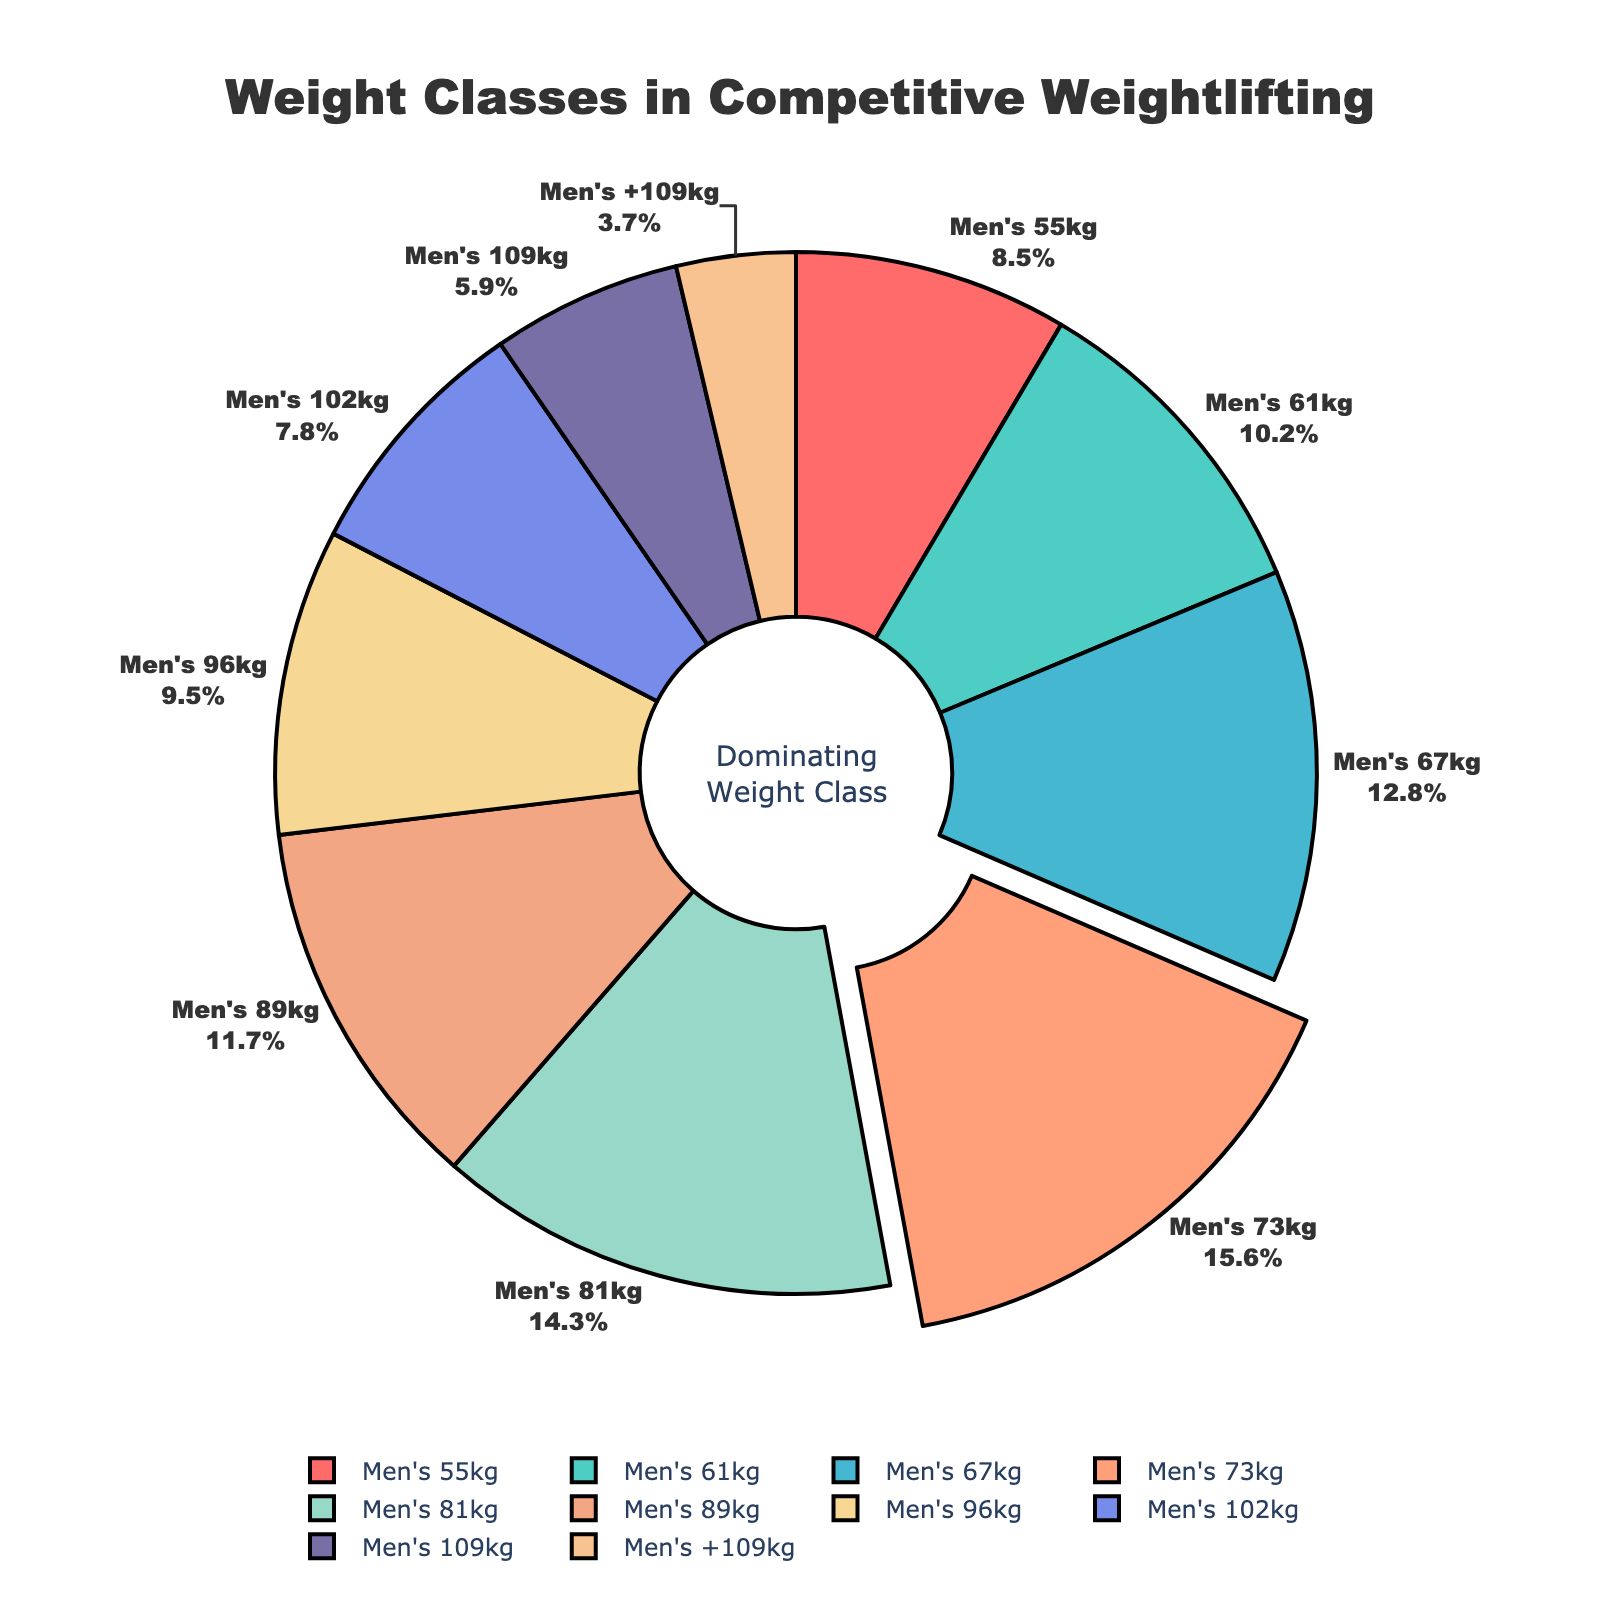Which weight class has the highest percentage? The weight class with the highest percentage will be the one with the largest slice on the pie chart. Observing the chart, the "Men's 73kg" class has the largest slice.
Answer: Men's 73kg What is the combined percentage of the Men's 96kg and Men's 81kg weight classes? To find the combined percentage, add the percentages of Men's 96kg and Men's 81kg. From the chart, Men's 96kg is 9.5% and Men's 81kg is 14.3%. Thus, 9.5% + 14.3% = 23.8%.
Answer: 23.8% Which weight class has the least representation? The weight class with the smallest slice on the pie chart represents the one with the least percentage. Noticing the chart, the "Men's +109kg" class has the smallest slice.
Answer: Men's +109kg How much larger is the percentage of Men's 67kg compared to Men's 55kg? To determine this, subtract the percentage of Men's 55kg from the percentage of Men's 67kg: Men's 67kg is 12.8% and Men's 55kg is 8.5%, so 12.8% - 8.5% = 4.3%.
Answer: 4.3% What is the total percentage of the three most represented weight classes? Identify the three largest slices: Men's 73kg (15.6%), Men's 67kg (12.8%), and Men's 81kg (14.3%). Adding these values, we get 15.6% + 12.8% + 14.3% = 42.7%.
Answer: 42.7% Which weight classes make up more than 10% each? Look for weight classes with slices larger than 10%. From the chart, these are Men's 61kg (10.2%), Men's 67kg (12.8%), Men's 73kg (15.6%), and Men's 81kg (14.3%).
Answer: Men's 61kg, Men's 67kg, Men's 73kg, Men's 81kg What is the average percentage of the Men's 102kg, Men's 109kg, and Men's +109kg weight classes? To find the average, sum their percentages and divide by the number of classes: (Men's 102kg = 7.8%, Men's 109kg = 5.9%, Men's +109kg = 3.7%), (7.8% + 5.9% + 3.7%) / 3 = 17.4% / 3 = 5.8%.
Answer: 5.8% How many weight classes have a percentage greater than 10%? Count the slices greater than 10%. These include Men's 61kg, Men's 67kg, Men's 73kg, and Men's 81kg, totaling 4 weight classes.
Answer: 4 What is the percentage difference between Men's 61kg and Men's 96kg? Subtract the percentage of Men's 96kg from Men's 61kg: 10.2% - 9.5% = 0.7%.
Answer: 0.7% 